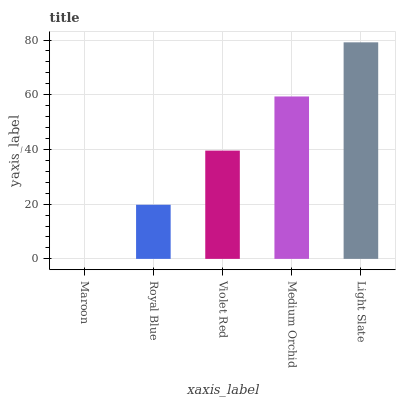Is Maroon the minimum?
Answer yes or no. Yes. Is Light Slate the maximum?
Answer yes or no. Yes. Is Royal Blue the minimum?
Answer yes or no. No. Is Royal Blue the maximum?
Answer yes or no. No. Is Royal Blue greater than Maroon?
Answer yes or no. Yes. Is Maroon less than Royal Blue?
Answer yes or no. Yes. Is Maroon greater than Royal Blue?
Answer yes or no. No. Is Royal Blue less than Maroon?
Answer yes or no. No. Is Violet Red the high median?
Answer yes or no. Yes. Is Violet Red the low median?
Answer yes or no. Yes. Is Maroon the high median?
Answer yes or no. No. Is Royal Blue the low median?
Answer yes or no. No. 